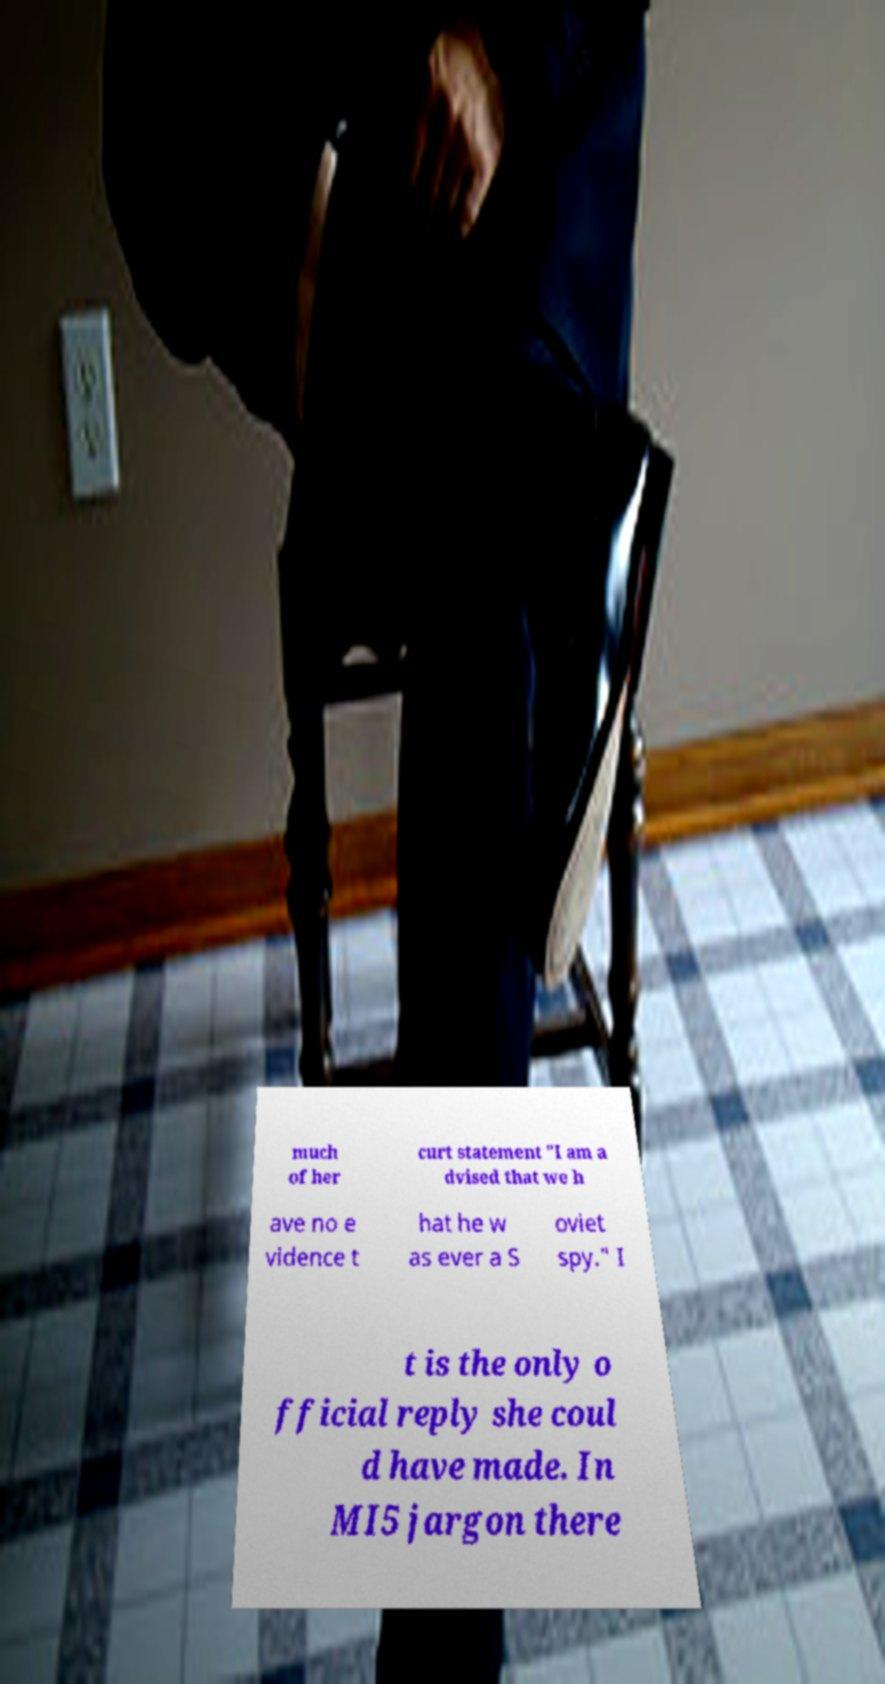I need the written content from this picture converted into text. Can you do that? much of her curt statement "I am a dvised that we h ave no e vidence t hat he w as ever a S oviet spy." I t is the only o fficial reply she coul d have made. In MI5 jargon there 